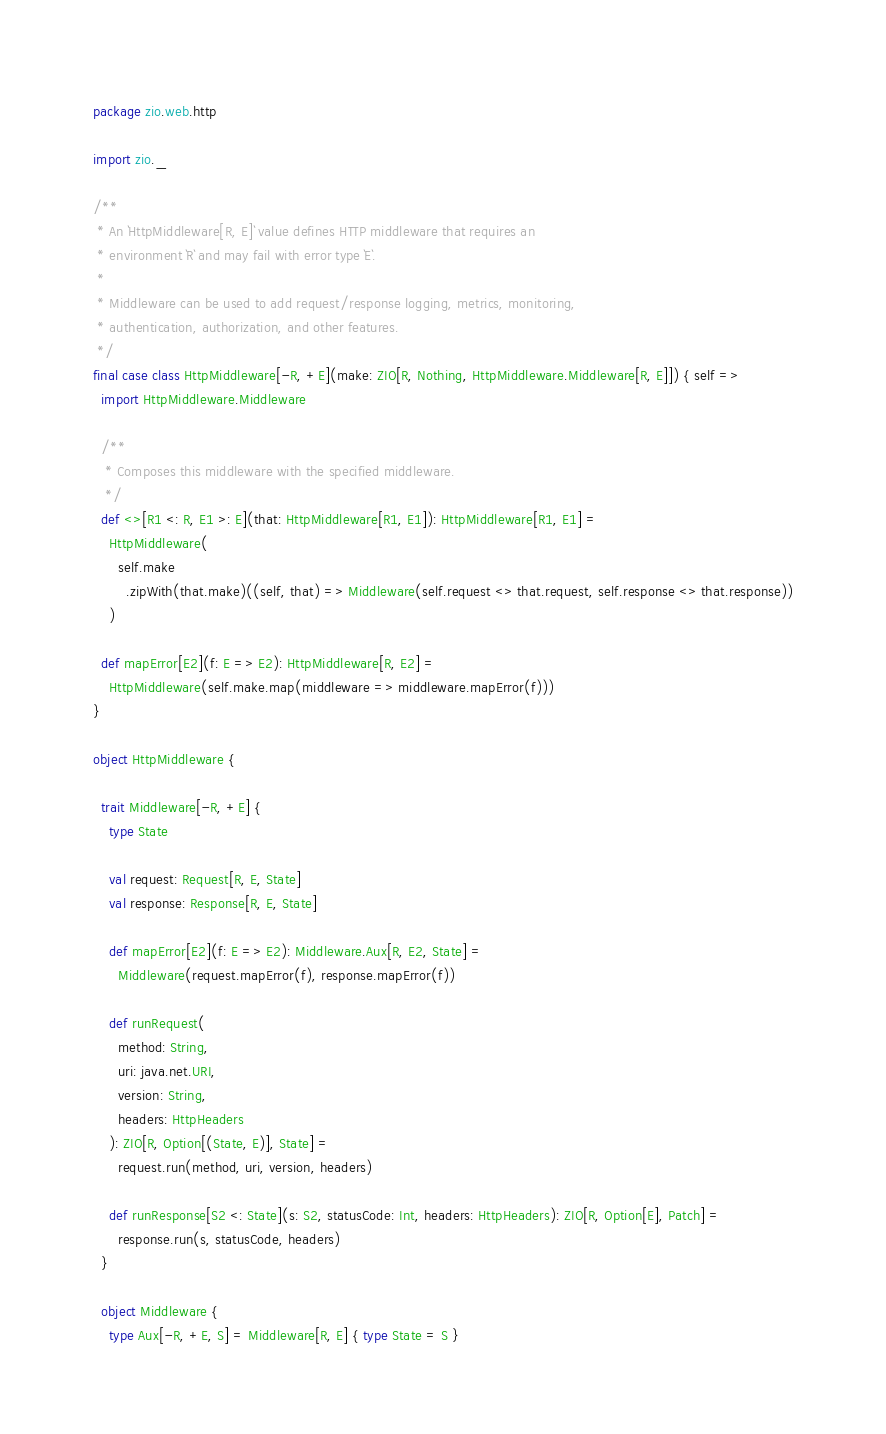Convert code to text. <code><loc_0><loc_0><loc_500><loc_500><_Scala_>package zio.web.http

import zio._

/**
 * An `HttpMiddleware[R, E]` value defines HTTP middleware that requires an
 * environment `R` and may fail with error type `E`.
 *
 * Middleware can be used to add request/response logging, metrics, monitoring,
 * authentication, authorization, and other features.
 */
final case class HttpMiddleware[-R, +E](make: ZIO[R, Nothing, HttpMiddleware.Middleware[R, E]]) { self =>
  import HttpMiddleware.Middleware

  /**
   * Composes this middleware with the specified middleware.
   */
  def <>[R1 <: R, E1 >: E](that: HttpMiddleware[R1, E1]): HttpMiddleware[R1, E1] =
    HttpMiddleware(
      self.make
        .zipWith(that.make)((self, that) => Middleware(self.request <> that.request, self.response <> that.response))
    )

  def mapError[E2](f: E => E2): HttpMiddleware[R, E2] =
    HttpMiddleware(self.make.map(middleware => middleware.mapError(f)))
}

object HttpMiddleware {

  trait Middleware[-R, +E] {
    type State

    val request: Request[R, E, State]
    val response: Response[R, E, State]

    def mapError[E2](f: E => E2): Middleware.Aux[R, E2, State] =
      Middleware(request.mapError(f), response.mapError(f))

    def runRequest(
      method: String,
      uri: java.net.URI,
      version: String,
      headers: HttpHeaders
    ): ZIO[R, Option[(State, E)], State] =
      request.run(method, uri, version, headers)

    def runResponse[S2 <: State](s: S2, statusCode: Int, headers: HttpHeaders): ZIO[R, Option[E], Patch] =
      response.run(s, statusCode, headers)
  }

  object Middleware {
    type Aux[-R, +E, S] = Middleware[R, E] { type State = S }
</code> 